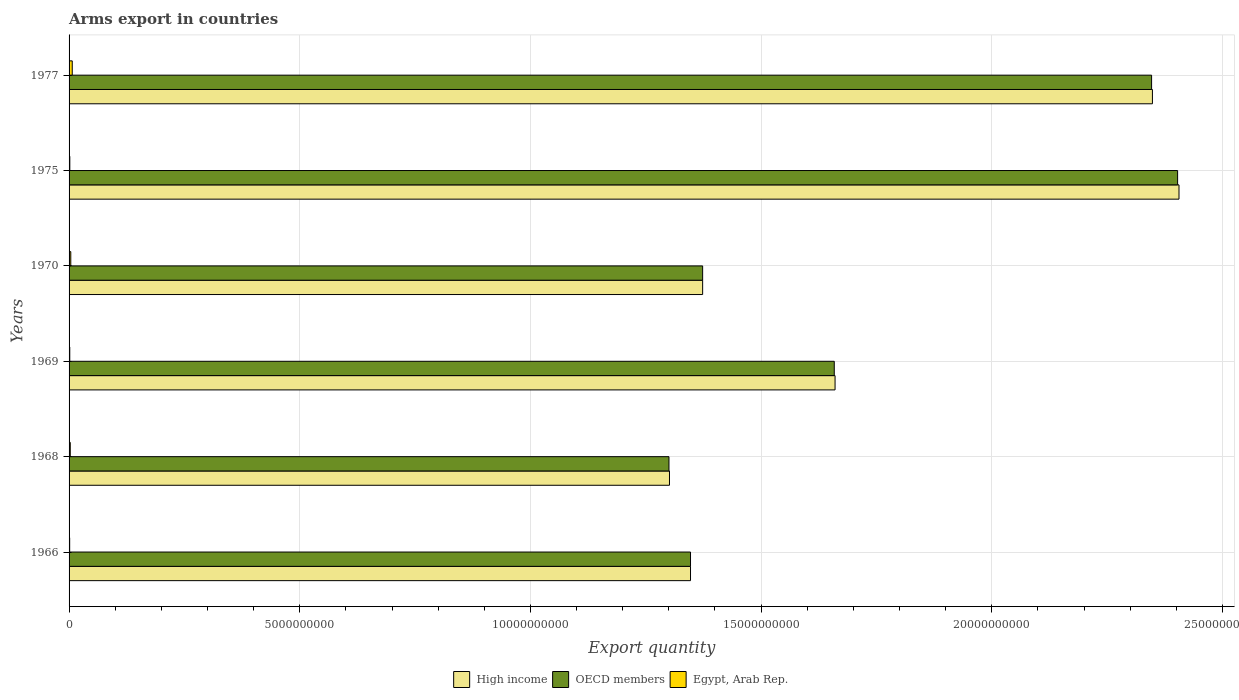How many different coloured bars are there?
Ensure brevity in your answer.  3. How many groups of bars are there?
Give a very brief answer. 6. Are the number of bars per tick equal to the number of legend labels?
Keep it short and to the point. Yes. How many bars are there on the 1st tick from the top?
Provide a short and direct response. 3. What is the label of the 3rd group of bars from the top?
Your response must be concise. 1970. What is the total arms export in OECD members in 1977?
Offer a terse response. 2.35e+1. Across all years, what is the maximum total arms export in High income?
Offer a very short reply. 2.41e+1. Across all years, what is the minimum total arms export in OECD members?
Your answer should be very brief. 1.30e+1. In which year was the total arms export in OECD members maximum?
Your answer should be compact. 1975. In which year was the total arms export in High income minimum?
Provide a short and direct response. 1968. What is the total total arms export in Egypt, Arab Rep. in the graph?
Your answer should be very brief. 1.76e+08. What is the difference between the total arms export in High income in 1969 and that in 1977?
Make the answer very short. -6.88e+09. What is the difference between the total arms export in Egypt, Arab Rep. in 1966 and the total arms export in High income in 1969?
Your answer should be very brief. -1.66e+1. What is the average total arms export in High income per year?
Keep it short and to the point. 1.74e+1. In the year 1977, what is the difference between the total arms export in High income and total arms export in OECD members?
Make the answer very short. 1.80e+07. What is the ratio of the total arms export in OECD members in 1969 to that in 1977?
Your answer should be compact. 0.71. What is the difference between the highest and the second highest total arms export in OECD members?
Make the answer very short. 5.64e+08. What is the difference between the highest and the lowest total arms export in High income?
Your response must be concise. 1.10e+1. In how many years, is the total arms export in High income greater than the average total arms export in High income taken over all years?
Offer a very short reply. 2. Is the sum of the total arms export in High income in 1969 and 1977 greater than the maximum total arms export in OECD members across all years?
Your answer should be very brief. Yes. What does the 3rd bar from the top in 1977 represents?
Give a very brief answer. High income. What does the 3rd bar from the bottom in 1966 represents?
Ensure brevity in your answer.  Egypt, Arab Rep. Are all the bars in the graph horizontal?
Offer a very short reply. Yes. How many years are there in the graph?
Offer a terse response. 6. What is the difference between two consecutive major ticks on the X-axis?
Offer a terse response. 5.00e+09. Are the values on the major ticks of X-axis written in scientific E-notation?
Make the answer very short. No. Does the graph contain grids?
Provide a succinct answer. Yes. Where does the legend appear in the graph?
Your answer should be compact. Bottom center. How many legend labels are there?
Ensure brevity in your answer.  3. How are the legend labels stacked?
Ensure brevity in your answer.  Horizontal. What is the title of the graph?
Make the answer very short. Arms export in countries. Does "Sub-Saharan Africa (all income levels)" appear as one of the legend labels in the graph?
Make the answer very short. No. What is the label or title of the X-axis?
Offer a terse response. Export quantity. What is the label or title of the Y-axis?
Give a very brief answer. Years. What is the Export quantity in High income in 1966?
Provide a short and direct response. 1.35e+1. What is the Export quantity of OECD members in 1966?
Your answer should be compact. 1.35e+1. What is the Export quantity in Egypt, Arab Rep. in 1966?
Ensure brevity in your answer.  1.30e+07. What is the Export quantity in High income in 1968?
Your answer should be compact. 1.30e+1. What is the Export quantity in OECD members in 1968?
Make the answer very short. 1.30e+1. What is the Export quantity of Egypt, Arab Rep. in 1968?
Provide a short and direct response. 2.60e+07. What is the Export quantity of High income in 1969?
Your response must be concise. 1.66e+1. What is the Export quantity in OECD members in 1969?
Keep it short and to the point. 1.66e+1. What is the Export quantity in Egypt, Arab Rep. in 1969?
Offer a terse response. 1.50e+07. What is the Export quantity of High income in 1970?
Provide a short and direct response. 1.37e+1. What is the Export quantity of OECD members in 1970?
Offer a terse response. 1.37e+1. What is the Export quantity of Egypt, Arab Rep. in 1970?
Ensure brevity in your answer.  3.70e+07. What is the Export quantity in High income in 1975?
Your answer should be compact. 2.41e+1. What is the Export quantity of OECD members in 1975?
Your response must be concise. 2.40e+1. What is the Export quantity in Egypt, Arab Rep. in 1975?
Your answer should be very brief. 1.60e+07. What is the Export quantity of High income in 1977?
Ensure brevity in your answer.  2.35e+1. What is the Export quantity in OECD members in 1977?
Keep it short and to the point. 2.35e+1. What is the Export quantity of Egypt, Arab Rep. in 1977?
Your response must be concise. 6.90e+07. Across all years, what is the maximum Export quantity of High income?
Your answer should be compact. 2.41e+1. Across all years, what is the maximum Export quantity in OECD members?
Make the answer very short. 2.40e+1. Across all years, what is the maximum Export quantity in Egypt, Arab Rep.?
Offer a terse response. 6.90e+07. Across all years, what is the minimum Export quantity in High income?
Keep it short and to the point. 1.30e+1. Across all years, what is the minimum Export quantity of OECD members?
Your answer should be compact. 1.30e+1. Across all years, what is the minimum Export quantity of Egypt, Arab Rep.?
Provide a succinct answer. 1.30e+07. What is the total Export quantity in High income in the graph?
Provide a succinct answer. 1.04e+11. What is the total Export quantity of OECD members in the graph?
Keep it short and to the point. 1.04e+11. What is the total Export quantity in Egypt, Arab Rep. in the graph?
Your answer should be compact. 1.76e+08. What is the difference between the Export quantity in High income in 1966 and that in 1968?
Provide a short and direct response. 4.56e+08. What is the difference between the Export quantity in OECD members in 1966 and that in 1968?
Your response must be concise. 4.67e+08. What is the difference between the Export quantity of Egypt, Arab Rep. in 1966 and that in 1968?
Provide a succinct answer. -1.30e+07. What is the difference between the Export quantity of High income in 1966 and that in 1969?
Ensure brevity in your answer.  -3.13e+09. What is the difference between the Export quantity in OECD members in 1966 and that in 1969?
Keep it short and to the point. -3.12e+09. What is the difference between the Export quantity in High income in 1966 and that in 1970?
Ensure brevity in your answer.  -2.63e+08. What is the difference between the Export quantity in OECD members in 1966 and that in 1970?
Make the answer very short. -2.63e+08. What is the difference between the Export quantity of Egypt, Arab Rep. in 1966 and that in 1970?
Offer a very short reply. -2.40e+07. What is the difference between the Export quantity in High income in 1966 and that in 1975?
Offer a very short reply. -1.06e+1. What is the difference between the Export quantity in OECD members in 1966 and that in 1975?
Provide a short and direct response. -1.06e+1. What is the difference between the Export quantity of Egypt, Arab Rep. in 1966 and that in 1975?
Offer a very short reply. -3.00e+06. What is the difference between the Export quantity of High income in 1966 and that in 1977?
Provide a short and direct response. -1.00e+1. What is the difference between the Export quantity of OECD members in 1966 and that in 1977?
Provide a succinct answer. -9.99e+09. What is the difference between the Export quantity of Egypt, Arab Rep. in 1966 and that in 1977?
Ensure brevity in your answer.  -5.60e+07. What is the difference between the Export quantity of High income in 1968 and that in 1969?
Provide a short and direct response. -3.59e+09. What is the difference between the Export quantity of OECD members in 1968 and that in 1969?
Provide a short and direct response. -3.58e+09. What is the difference between the Export quantity of Egypt, Arab Rep. in 1968 and that in 1969?
Give a very brief answer. 1.10e+07. What is the difference between the Export quantity in High income in 1968 and that in 1970?
Make the answer very short. -7.19e+08. What is the difference between the Export quantity of OECD members in 1968 and that in 1970?
Offer a terse response. -7.30e+08. What is the difference between the Export quantity in Egypt, Arab Rep. in 1968 and that in 1970?
Offer a terse response. -1.10e+07. What is the difference between the Export quantity of High income in 1968 and that in 1975?
Your answer should be very brief. -1.10e+1. What is the difference between the Export quantity of OECD members in 1968 and that in 1975?
Ensure brevity in your answer.  -1.10e+1. What is the difference between the Export quantity in High income in 1968 and that in 1977?
Make the answer very short. -1.05e+1. What is the difference between the Export quantity in OECD members in 1968 and that in 1977?
Your response must be concise. -1.05e+1. What is the difference between the Export quantity in Egypt, Arab Rep. in 1968 and that in 1977?
Provide a short and direct response. -4.30e+07. What is the difference between the Export quantity of High income in 1969 and that in 1970?
Give a very brief answer. 2.87e+09. What is the difference between the Export quantity in OECD members in 1969 and that in 1970?
Make the answer very short. 2.85e+09. What is the difference between the Export quantity in Egypt, Arab Rep. in 1969 and that in 1970?
Offer a terse response. -2.20e+07. What is the difference between the Export quantity in High income in 1969 and that in 1975?
Your response must be concise. -7.46e+09. What is the difference between the Export quantity of OECD members in 1969 and that in 1975?
Ensure brevity in your answer.  -7.44e+09. What is the difference between the Export quantity of Egypt, Arab Rep. in 1969 and that in 1975?
Your answer should be very brief. -1.00e+06. What is the difference between the Export quantity of High income in 1969 and that in 1977?
Give a very brief answer. -6.88e+09. What is the difference between the Export quantity in OECD members in 1969 and that in 1977?
Ensure brevity in your answer.  -6.88e+09. What is the difference between the Export quantity in Egypt, Arab Rep. in 1969 and that in 1977?
Make the answer very short. -5.40e+07. What is the difference between the Export quantity in High income in 1970 and that in 1975?
Your response must be concise. -1.03e+1. What is the difference between the Export quantity in OECD members in 1970 and that in 1975?
Your response must be concise. -1.03e+1. What is the difference between the Export quantity in Egypt, Arab Rep. in 1970 and that in 1975?
Offer a very short reply. 2.10e+07. What is the difference between the Export quantity of High income in 1970 and that in 1977?
Offer a very short reply. -9.75e+09. What is the difference between the Export quantity of OECD members in 1970 and that in 1977?
Provide a succinct answer. -9.73e+09. What is the difference between the Export quantity of Egypt, Arab Rep. in 1970 and that in 1977?
Provide a short and direct response. -3.20e+07. What is the difference between the Export quantity of High income in 1975 and that in 1977?
Provide a succinct answer. 5.76e+08. What is the difference between the Export quantity in OECD members in 1975 and that in 1977?
Give a very brief answer. 5.64e+08. What is the difference between the Export quantity of Egypt, Arab Rep. in 1975 and that in 1977?
Your answer should be compact. -5.30e+07. What is the difference between the Export quantity of High income in 1966 and the Export quantity of OECD members in 1968?
Your answer should be very brief. 4.67e+08. What is the difference between the Export quantity in High income in 1966 and the Export quantity in Egypt, Arab Rep. in 1968?
Keep it short and to the point. 1.34e+1. What is the difference between the Export quantity of OECD members in 1966 and the Export quantity of Egypt, Arab Rep. in 1968?
Offer a very short reply. 1.34e+1. What is the difference between the Export quantity in High income in 1966 and the Export quantity in OECD members in 1969?
Ensure brevity in your answer.  -3.12e+09. What is the difference between the Export quantity in High income in 1966 and the Export quantity in Egypt, Arab Rep. in 1969?
Offer a terse response. 1.35e+1. What is the difference between the Export quantity of OECD members in 1966 and the Export quantity of Egypt, Arab Rep. in 1969?
Offer a terse response. 1.35e+1. What is the difference between the Export quantity in High income in 1966 and the Export quantity in OECD members in 1970?
Offer a very short reply. -2.63e+08. What is the difference between the Export quantity in High income in 1966 and the Export quantity in Egypt, Arab Rep. in 1970?
Offer a very short reply. 1.34e+1. What is the difference between the Export quantity of OECD members in 1966 and the Export quantity of Egypt, Arab Rep. in 1970?
Make the answer very short. 1.34e+1. What is the difference between the Export quantity of High income in 1966 and the Export quantity of OECD members in 1975?
Offer a terse response. -1.06e+1. What is the difference between the Export quantity of High income in 1966 and the Export quantity of Egypt, Arab Rep. in 1975?
Your answer should be very brief. 1.35e+1. What is the difference between the Export quantity in OECD members in 1966 and the Export quantity in Egypt, Arab Rep. in 1975?
Offer a terse response. 1.35e+1. What is the difference between the Export quantity in High income in 1966 and the Export quantity in OECD members in 1977?
Provide a succinct answer. -9.99e+09. What is the difference between the Export quantity of High income in 1966 and the Export quantity of Egypt, Arab Rep. in 1977?
Ensure brevity in your answer.  1.34e+1. What is the difference between the Export quantity in OECD members in 1966 and the Export quantity in Egypt, Arab Rep. in 1977?
Make the answer very short. 1.34e+1. What is the difference between the Export quantity in High income in 1968 and the Export quantity in OECD members in 1969?
Keep it short and to the point. -3.57e+09. What is the difference between the Export quantity of High income in 1968 and the Export quantity of Egypt, Arab Rep. in 1969?
Ensure brevity in your answer.  1.30e+1. What is the difference between the Export quantity in OECD members in 1968 and the Export quantity in Egypt, Arab Rep. in 1969?
Your answer should be very brief. 1.30e+1. What is the difference between the Export quantity of High income in 1968 and the Export quantity of OECD members in 1970?
Your answer should be very brief. -7.19e+08. What is the difference between the Export quantity in High income in 1968 and the Export quantity in Egypt, Arab Rep. in 1970?
Your response must be concise. 1.30e+1. What is the difference between the Export quantity of OECD members in 1968 and the Export quantity of Egypt, Arab Rep. in 1970?
Your response must be concise. 1.30e+1. What is the difference between the Export quantity in High income in 1968 and the Export quantity in OECD members in 1975?
Your answer should be very brief. -1.10e+1. What is the difference between the Export quantity of High income in 1968 and the Export quantity of Egypt, Arab Rep. in 1975?
Offer a terse response. 1.30e+1. What is the difference between the Export quantity in OECD members in 1968 and the Export quantity in Egypt, Arab Rep. in 1975?
Your answer should be compact. 1.30e+1. What is the difference between the Export quantity of High income in 1968 and the Export quantity of OECD members in 1977?
Your answer should be compact. -1.04e+1. What is the difference between the Export quantity in High income in 1968 and the Export quantity in Egypt, Arab Rep. in 1977?
Provide a succinct answer. 1.29e+1. What is the difference between the Export quantity in OECD members in 1968 and the Export quantity in Egypt, Arab Rep. in 1977?
Your answer should be very brief. 1.29e+1. What is the difference between the Export quantity of High income in 1969 and the Export quantity of OECD members in 1970?
Offer a terse response. 2.87e+09. What is the difference between the Export quantity of High income in 1969 and the Export quantity of Egypt, Arab Rep. in 1970?
Ensure brevity in your answer.  1.66e+1. What is the difference between the Export quantity in OECD members in 1969 and the Export quantity in Egypt, Arab Rep. in 1970?
Offer a very short reply. 1.65e+1. What is the difference between the Export quantity in High income in 1969 and the Export quantity in OECD members in 1975?
Provide a short and direct response. -7.42e+09. What is the difference between the Export quantity of High income in 1969 and the Export quantity of Egypt, Arab Rep. in 1975?
Provide a short and direct response. 1.66e+1. What is the difference between the Export quantity of OECD members in 1969 and the Export quantity of Egypt, Arab Rep. in 1975?
Your answer should be compact. 1.66e+1. What is the difference between the Export quantity in High income in 1969 and the Export quantity in OECD members in 1977?
Keep it short and to the point. -6.86e+09. What is the difference between the Export quantity of High income in 1969 and the Export quantity of Egypt, Arab Rep. in 1977?
Keep it short and to the point. 1.65e+1. What is the difference between the Export quantity in OECD members in 1969 and the Export quantity in Egypt, Arab Rep. in 1977?
Keep it short and to the point. 1.65e+1. What is the difference between the Export quantity in High income in 1970 and the Export quantity in OECD members in 1975?
Your answer should be compact. -1.03e+1. What is the difference between the Export quantity in High income in 1970 and the Export quantity in Egypt, Arab Rep. in 1975?
Keep it short and to the point. 1.37e+1. What is the difference between the Export quantity of OECD members in 1970 and the Export quantity of Egypt, Arab Rep. in 1975?
Offer a terse response. 1.37e+1. What is the difference between the Export quantity in High income in 1970 and the Export quantity in OECD members in 1977?
Provide a succinct answer. -9.73e+09. What is the difference between the Export quantity in High income in 1970 and the Export quantity in Egypt, Arab Rep. in 1977?
Your answer should be compact. 1.37e+1. What is the difference between the Export quantity of OECD members in 1970 and the Export quantity of Egypt, Arab Rep. in 1977?
Your response must be concise. 1.37e+1. What is the difference between the Export quantity of High income in 1975 and the Export quantity of OECD members in 1977?
Provide a short and direct response. 5.94e+08. What is the difference between the Export quantity in High income in 1975 and the Export quantity in Egypt, Arab Rep. in 1977?
Keep it short and to the point. 2.40e+1. What is the difference between the Export quantity in OECD members in 1975 and the Export quantity in Egypt, Arab Rep. in 1977?
Your response must be concise. 2.40e+1. What is the average Export quantity of High income per year?
Your answer should be very brief. 1.74e+1. What is the average Export quantity in OECD members per year?
Your answer should be compact. 1.74e+1. What is the average Export quantity of Egypt, Arab Rep. per year?
Provide a succinct answer. 2.93e+07. In the year 1966, what is the difference between the Export quantity of High income and Export quantity of OECD members?
Your answer should be very brief. 0. In the year 1966, what is the difference between the Export quantity of High income and Export quantity of Egypt, Arab Rep.?
Give a very brief answer. 1.35e+1. In the year 1966, what is the difference between the Export quantity in OECD members and Export quantity in Egypt, Arab Rep.?
Provide a succinct answer. 1.35e+1. In the year 1968, what is the difference between the Export quantity in High income and Export quantity in OECD members?
Your answer should be very brief. 1.10e+07. In the year 1968, what is the difference between the Export quantity in High income and Export quantity in Egypt, Arab Rep.?
Give a very brief answer. 1.30e+1. In the year 1968, what is the difference between the Export quantity in OECD members and Export quantity in Egypt, Arab Rep.?
Your answer should be very brief. 1.30e+1. In the year 1969, what is the difference between the Export quantity of High income and Export quantity of OECD members?
Ensure brevity in your answer.  1.70e+07. In the year 1969, what is the difference between the Export quantity of High income and Export quantity of Egypt, Arab Rep.?
Offer a terse response. 1.66e+1. In the year 1969, what is the difference between the Export quantity of OECD members and Export quantity of Egypt, Arab Rep.?
Make the answer very short. 1.66e+1. In the year 1970, what is the difference between the Export quantity of High income and Export quantity of OECD members?
Your response must be concise. 0. In the year 1970, what is the difference between the Export quantity of High income and Export quantity of Egypt, Arab Rep.?
Your response must be concise. 1.37e+1. In the year 1970, what is the difference between the Export quantity of OECD members and Export quantity of Egypt, Arab Rep.?
Keep it short and to the point. 1.37e+1. In the year 1975, what is the difference between the Export quantity of High income and Export quantity of OECD members?
Your response must be concise. 3.00e+07. In the year 1975, what is the difference between the Export quantity in High income and Export quantity in Egypt, Arab Rep.?
Ensure brevity in your answer.  2.40e+1. In the year 1975, what is the difference between the Export quantity in OECD members and Export quantity in Egypt, Arab Rep.?
Your answer should be compact. 2.40e+1. In the year 1977, what is the difference between the Export quantity in High income and Export quantity in OECD members?
Offer a terse response. 1.80e+07. In the year 1977, what is the difference between the Export quantity in High income and Export quantity in Egypt, Arab Rep.?
Your answer should be compact. 2.34e+1. In the year 1977, what is the difference between the Export quantity of OECD members and Export quantity of Egypt, Arab Rep.?
Give a very brief answer. 2.34e+1. What is the ratio of the Export quantity in High income in 1966 to that in 1968?
Your answer should be compact. 1.03. What is the ratio of the Export quantity of OECD members in 1966 to that in 1968?
Provide a succinct answer. 1.04. What is the ratio of the Export quantity of Egypt, Arab Rep. in 1966 to that in 1968?
Provide a succinct answer. 0.5. What is the ratio of the Export quantity of High income in 1966 to that in 1969?
Keep it short and to the point. 0.81. What is the ratio of the Export quantity of OECD members in 1966 to that in 1969?
Keep it short and to the point. 0.81. What is the ratio of the Export quantity in Egypt, Arab Rep. in 1966 to that in 1969?
Provide a succinct answer. 0.87. What is the ratio of the Export quantity in High income in 1966 to that in 1970?
Keep it short and to the point. 0.98. What is the ratio of the Export quantity of OECD members in 1966 to that in 1970?
Provide a short and direct response. 0.98. What is the ratio of the Export quantity of Egypt, Arab Rep. in 1966 to that in 1970?
Provide a succinct answer. 0.35. What is the ratio of the Export quantity in High income in 1966 to that in 1975?
Your response must be concise. 0.56. What is the ratio of the Export quantity of OECD members in 1966 to that in 1975?
Offer a terse response. 0.56. What is the ratio of the Export quantity of Egypt, Arab Rep. in 1966 to that in 1975?
Offer a terse response. 0.81. What is the ratio of the Export quantity of High income in 1966 to that in 1977?
Your answer should be compact. 0.57. What is the ratio of the Export quantity of OECD members in 1966 to that in 1977?
Your response must be concise. 0.57. What is the ratio of the Export quantity of Egypt, Arab Rep. in 1966 to that in 1977?
Offer a very short reply. 0.19. What is the ratio of the Export quantity in High income in 1968 to that in 1969?
Provide a short and direct response. 0.78. What is the ratio of the Export quantity of OECD members in 1968 to that in 1969?
Your response must be concise. 0.78. What is the ratio of the Export quantity in Egypt, Arab Rep. in 1968 to that in 1969?
Give a very brief answer. 1.73. What is the ratio of the Export quantity in High income in 1968 to that in 1970?
Ensure brevity in your answer.  0.95. What is the ratio of the Export quantity in OECD members in 1968 to that in 1970?
Provide a short and direct response. 0.95. What is the ratio of the Export quantity of Egypt, Arab Rep. in 1968 to that in 1970?
Keep it short and to the point. 0.7. What is the ratio of the Export quantity in High income in 1968 to that in 1975?
Make the answer very short. 0.54. What is the ratio of the Export quantity of OECD members in 1968 to that in 1975?
Keep it short and to the point. 0.54. What is the ratio of the Export quantity in Egypt, Arab Rep. in 1968 to that in 1975?
Make the answer very short. 1.62. What is the ratio of the Export quantity of High income in 1968 to that in 1977?
Your answer should be compact. 0.55. What is the ratio of the Export quantity of OECD members in 1968 to that in 1977?
Provide a short and direct response. 0.55. What is the ratio of the Export quantity in Egypt, Arab Rep. in 1968 to that in 1977?
Offer a terse response. 0.38. What is the ratio of the Export quantity of High income in 1969 to that in 1970?
Ensure brevity in your answer.  1.21. What is the ratio of the Export quantity of OECD members in 1969 to that in 1970?
Give a very brief answer. 1.21. What is the ratio of the Export quantity in Egypt, Arab Rep. in 1969 to that in 1970?
Your answer should be very brief. 0.41. What is the ratio of the Export quantity of High income in 1969 to that in 1975?
Offer a very short reply. 0.69. What is the ratio of the Export quantity of OECD members in 1969 to that in 1975?
Keep it short and to the point. 0.69. What is the ratio of the Export quantity in Egypt, Arab Rep. in 1969 to that in 1975?
Make the answer very short. 0.94. What is the ratio of the Export quantity of High income in 1969 to that in 1977?
Your answer should be very brief. 0.71. What is the ratio of the Export quantity of OECD members in 1969 to that in 1977?
Your answer should be compact. 0.71. What is the ratio of the Export quantity in Egypt, Arab Rep. in 1969 to that in 1977?
Your response must be concise. 0.22. What is the ratio of the Export quantity of High income in 1970 to that in 1975?
Provide a succinct answer. 0.57. What is the ratio of the Export quantity in OECD members in 1970 to that in 1975?
Your answer should be compact. 0.57. What is the ratio of the Export quantity in Egypt, Arab Rep. in 1970 to that in 1975?
Offer a terse response. 2.31. What is the ratio of the Export quantity in High income in 1970 to that in 1977?
Offer a terse response. 0.58. What is the ratio of the Export quantity in OECD members in 1970 to that in 1977?
Your answer should be very brief. 0.59. What is the ratio of the Export quantity of Egypt, Arab Rep. in 1970 to that in 1977?
Your answer should be compact. 0.54. What is the ratio of the Export quantity in High income in 1975 to that in 1977?
Make the answer very short. 1.02. What is the ratio of the Export quantity in OECD members in 1975 to that in 1977?
Your answer should be compact. 1.02. What is the ratio of the Export quantity of Egypt, Arab Rep. in 1975 to that in 1977?
Keep it short and to the point. 0.23. What is the difference between the highest and the second highest Export quantity of High income?
Provide a succinct answer. 5.76e+08. What is the difference between the highest and the second highest Export quantity of OECD members?
Make the answer very short. 5.64e+08. What is the difference between the highest and the second highest Export quantity of Egypt, Arab Rep.?
Give a very brief answer. 3.20e+07. What is the difference between the highest and the lowest Export quantity in High income?
Offer a very short reply. 1.10e+1. What is the difference between the highest and the lowest Export quantity in OECD members?
Offer a very short reply. 1.10e+1. What is the difference between the highest and the lowest Export quantity in Egypt, Arab Rep.?
Keep it short and to the point. 5.60e+07. 